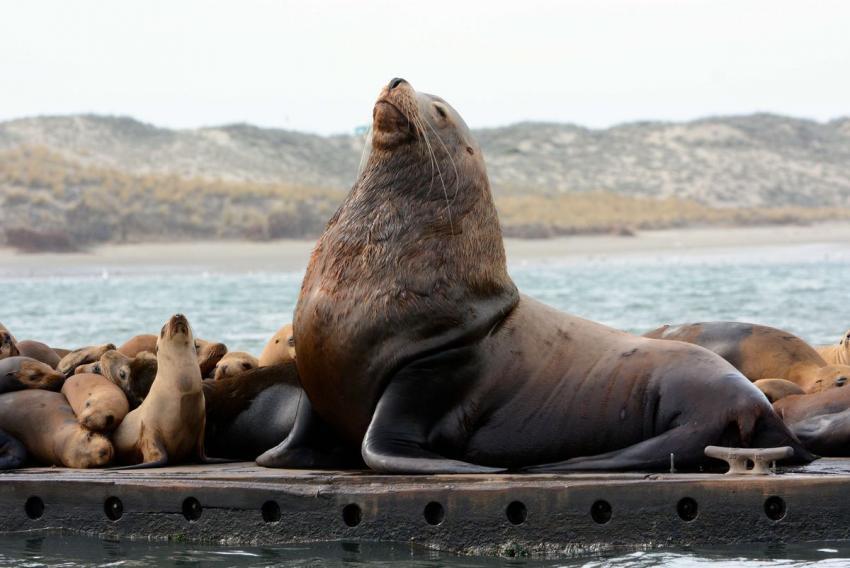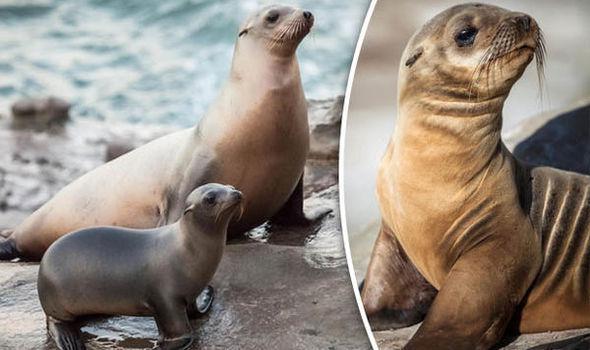The first image is the image on the left, the second image is the image on the right. Given the left and right images, does the statement "An image shows one large seal with raised head amidst multiple smaller seals." hold true? Answer yes or no. Yes. 